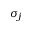<formula> <loc_0><loc_0><loc_500><loc_500>\sigma _ { j }</formula> 